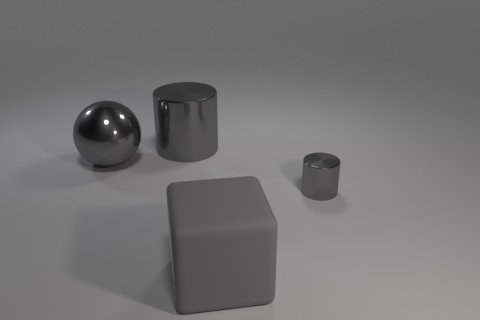How many things are shiny cylinders or gray cylinders left of the rubber cube?
Make the answer very short. 2. Are there any other things that have the same shape as the tiny gray object?
Offer a very short reply. Yes. Does the gray thing that is right of the gray rubber thing have the same size as the big gray sphere?
Keep it short and to the point. No. How many shiny things are either tiny blue cylinders or cubes?
Your response must be concise. 0. There is a gray cylinder behind the small gray object; what size is it?
Your response must be concise. Large. Does the tiny thing have the same shape as the large gray rubber object?
Offer a very short reply. No. What number of tiny objects are gray metal cylinders or gray rubber cubes?
Offer a terse response. 1. There is a small gray cylinder; are there any objects behind it?
Your response must be concise. Yes. Are there the same number of large rubber cubes behind the large gray block and big cylinders?
Offer a terse response. No. There is another gray thing that is the same shape as the tiny shiny object; what is its size?
Provide a short and direct response. Large. 